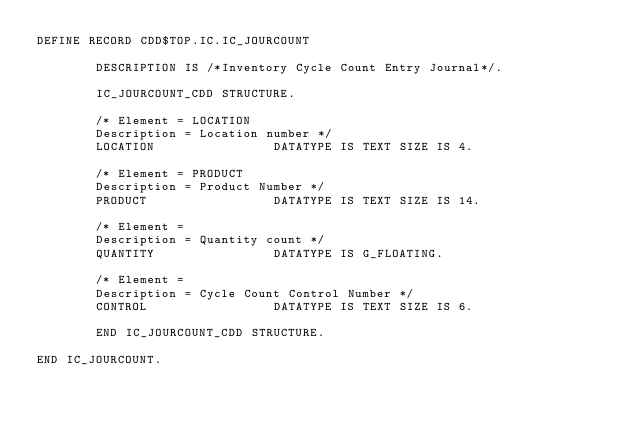<code> <loc_0><loc_0><loc_500><loc_500><_SQL_>DEFINE RECORD CDD$TOP.IC.IC_JOURCOUNT

        DESCRIPTION IS /*Inventory Cycle Count Entry Journal*/.

        IC_JOURCOUNT_CDD STRUCTURE.

        /* Element = LOCATION
        Description = Location number */
        LOCATION                DATATYPE IS TEXT SIZE IS 4.

        /* Element = PRODUCT
        Description = Product Number */
        PRODUCT                 DATATYPE IS TEXT SIZE IS 14.

        /* Element =
        Description = Quantity count */
        QUANTITY                DATATYPE IS G_FLOATING.

        /* Element =
        Description = Cycle Count Control Number */
        CONTROL                 DATATYPE IS TEXT SIZE IS 6.

        END IC_JOURCOUNT_CDD STRUCTURE.

END IC_JOURCOUNT.
</code> 